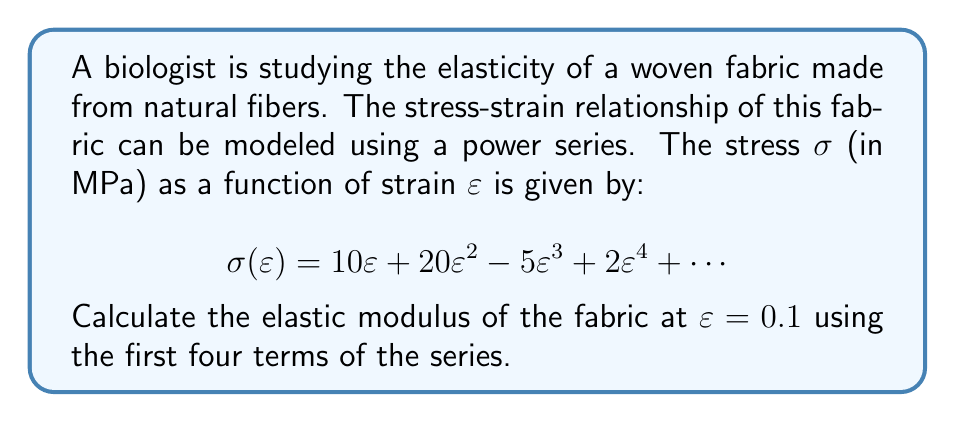Help me with this question. To solve this problem, we'll follow these steps:

1) The elastic modulus is defined as the derivative of stress with respect to strain:

   $$E = \frac{d\sigma}{d\varepsilon}$$

2) We need to differentiate the given power series. Let's do this term by term:
   
   $$\frac{d}{d\varepsilon}(10\varepsilon) = 10$$
   $$\frac{d}{d\varepsilon}(20\varepsilon^2) = 40\varepsilon$$
   $$\frac{d}{d\varepsilon}(-5\varepsilon^3) = -15\varepsilon^2$$
   $$\frac{d}{d\varepsilon}(2\varepsilon^4) = 8\varepsilon^3$$

3) Combining these terms, we get the elastic modulus function:

   $$E(\varepsilon) = 10 + 40\varepsilon - 15\varepsilon^2 + 8\varepsilon^3$$

4) Now, we need to evaluate this at $\varepsilon = 0.1$:

   $$E(0.1) = 10 + 40(0.1) - 15(0.1)^2 + 8(0.1)^3$$

5) Let's calculate each term:
   
   $$10 = 10$$
   $$40(0.1) = 4$$
   $$-15(0.1)^2 = -15(0.01) = -0.15$$
   $$8(0.1)^3 = 8(0.001) = 0.008$$

6) Sum up all the terms:

   $$E(0.1) = 10 + 4 - 0.15 + 0.008 = 13.858$$

Therefore, the elastic modulus of the fabric at $\varepsilon = 0.1$ is approximately 13.858 MPa.
Answer: 13.858 MPa 